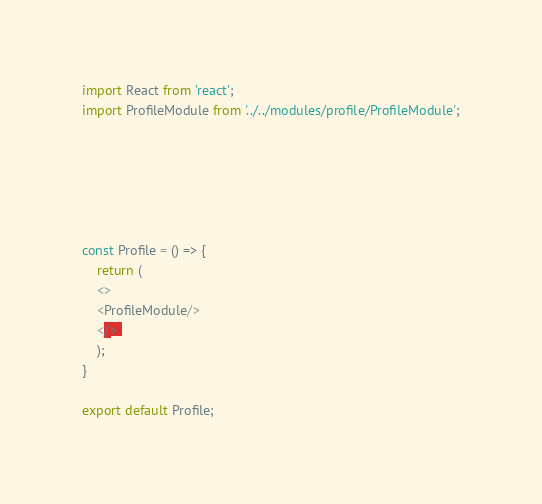<code> <loc_0><loc_0><loc_500><loc_500><_JavaScript_>import React from 'react';
import ProfileModule from '../../modules/profile/ProfileModule';






const Profile = () => {
    return ( 
    <>
    <ProfileModule/>
    </> 
    );
}
 
export default Profile;</code> 